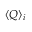Convert formula to latex. <formula><loc_0><loc_0><loc_500><loc_500>\langle Q \rangle _ { i }</formula> 